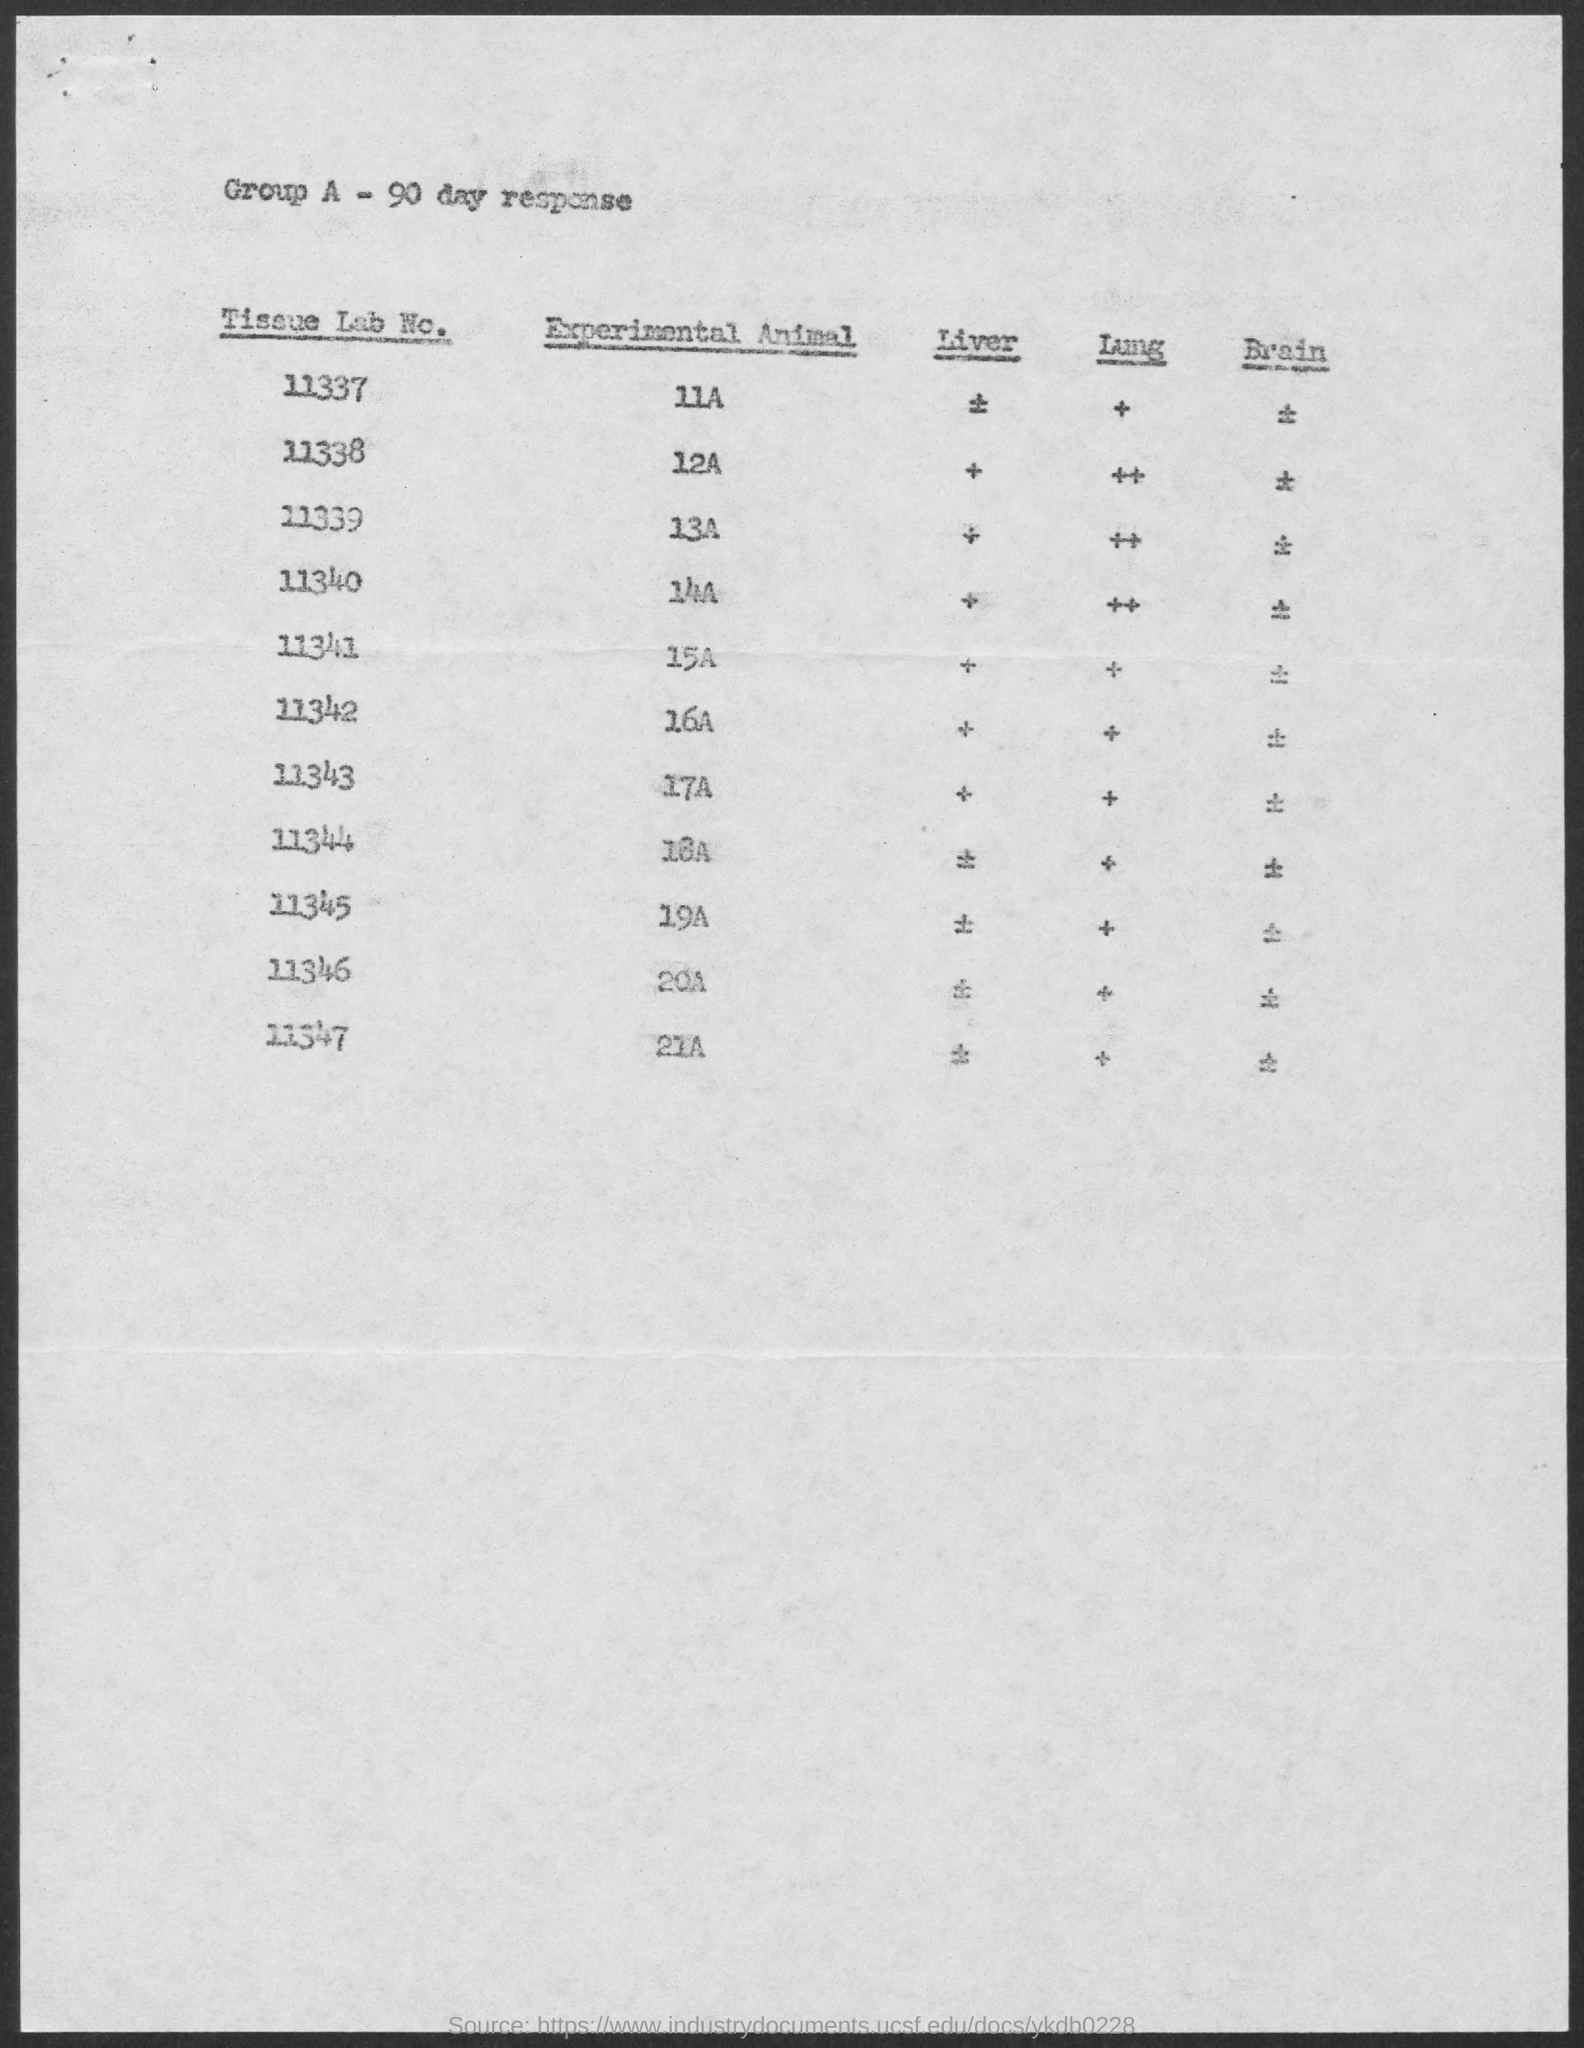Indicate a few pertinent items in this graphic. The experimental animal, designated as 21A, is located in a tissue lab with the identifier 11347. The experimental animal 18A is located in a tissue laboratory, as denoted by the numerical code 11344... The experimental animal 14A is located in a tissue laboratory, with a unique identification number of 11340. The animal that is in tissue lab number 11346 for the experiment is a 20A. The animal that is in tissue lab no. 11343 for the experiment is a 17A. 